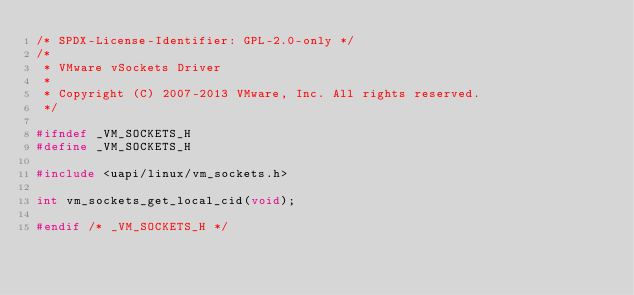Convert code to text. <code><loc_0><loc_0><loc_500><loc_500><_C_>/* SPDX-License-Identifier: GPL-2.0-only */
/*
 * VMware vSockets Driver
 *
 * Copyright (C) 2007-2013 VMware, Inc. All rights reserved.
 */

#ifndef _VM_SOCKETS_H
#define _VM_SOCKETS_H

#include <uapi/linux/vm_sockets.h>

int vm_sockets_get_local_cid(void);

#endif /* _VM_SOCKETS_H */
</code> 